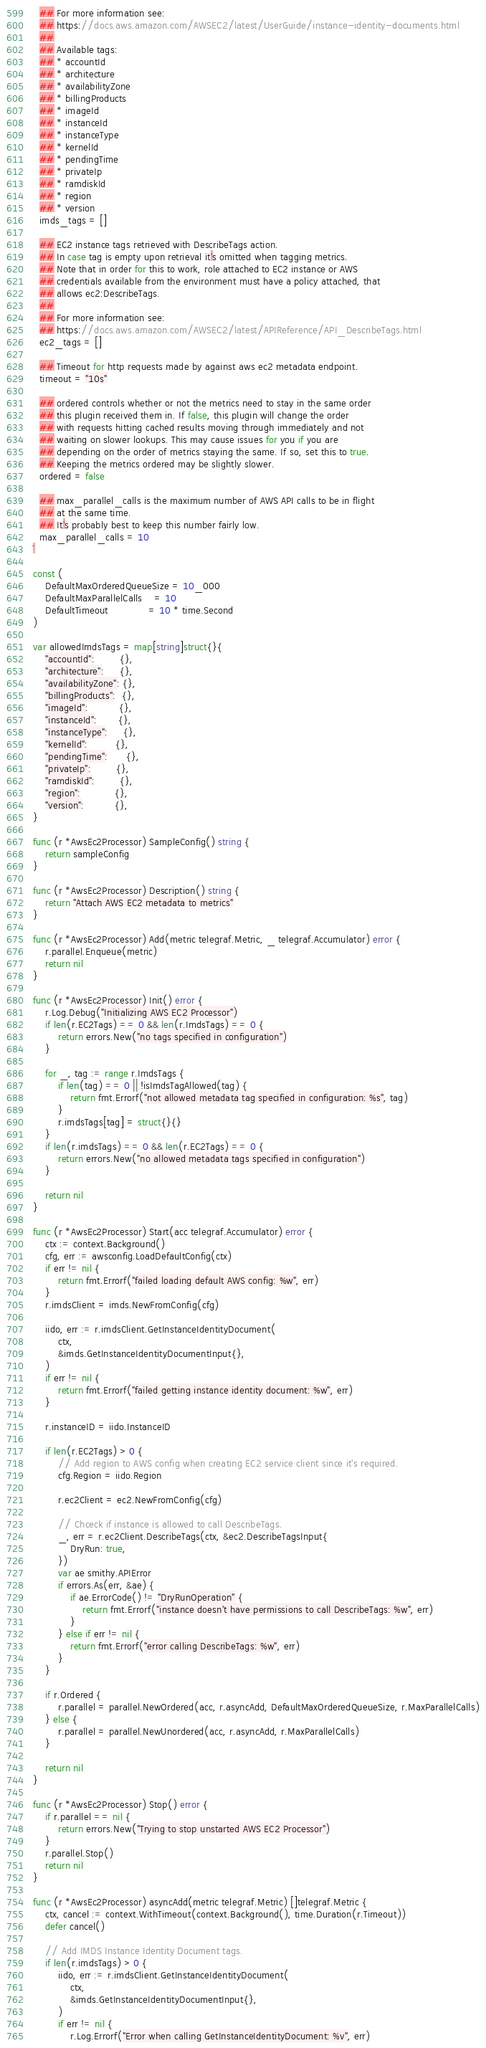Convert code to text. <code><loc_0><loc_0><loc_500><loc_500><_Go_>  ## For more information see:
  ## https://docs.aws.amazon.com/AWSEC2/latest/UserGuide/instance-identity-documents.html
  ##
  ## Available tags:
  ## * accountId
  ## * architecture
  ## * availabilityZone
  ## * billingProducts
  ## * imageId
  ## * instanceId
  ## * instanceType
  ## * kernelId
  ## * pendingTime
  ## * privateIp
  ## * ramdiskId
  ## * region
  ## * version
  imds_tags = []

  ## EC2 instance tags retrieved with DescribeTags action.
  ## In case tag is empty upon retrieval it's omitted when tagging metrics.
  ## Note that in order for this to work, role attached to EC2 instance or AWS
  ## credentials available from the environment must have a policy attached, that
  ## allows ec2:DescribeTags.
  ##
  ## For more information see:
  ## https://docs.aws.amazon.com/AWSEC2/latest/APIReference/API_DescribeTags.html
  ec2_tags = []

  ## Timeout for http requests made by against aws ec2 metadata endpoint.
  timeout = "10s"

  ## ordered controls whether or not the metrics need to stay in the same order
  ## this plugin received them in. If false, this plugin will change the order
  ## with requests hitting cached results moving through immediately and not
  ## waiting on slower lookups. This may cause issues for you if you are
  ## depending on the order of metrics staying the same. If so, set this to true.
  ## Keeping the metrics ordered may be slightly slower.
  ordered = false

  ## max_parallel_calls is the maximum number of AWS API calls to be in flight
  ## at the same time.
  ## It's probably best to keep this number fairly low.
  max_parallel_calls = 10
`

const (
	DefaultMaxOrderedQueueSize = 10_000
	DefaultMaxParallelCalls    = 10
	DefaultTimeout             = 10 * time.Second
)

var allowedImdsTags = map[string]struct{}{
	"accountId":        {},
	"architecture":     {},
	"availabilityZone": {},
	"billingProducts":  {},
	"imageId":          {},
	"instanceId":       {},
	"instanceType":     {},
	"kernelId":         {},
	"pendingTime":      {},
	"privateIp":        {},
	"ramdiskId":        {},
	"region":           {},
	"version":          {},
}

func (r *AwsEc2Processor) SampleConfig() string {
	return sampleConfig
}

func (r *AwsEc2Processor) Description() string {
	return "Attach AWS EC2 metadata to metrics"
}

func (r *AwsEc2Processor) Add(metric telegraf.Metric, _ telegraf.Accumulator) error {
	r.parallel.Enqueue(metric)
	return nil
}

func (r *AwsEc2Processor) Init() error {
	r.Log.Debug("Initializing AWS EC2 Processor")
	if len(r.EC2Tags) == 0 && len(r.ImdsTags) == 0 {
		return errors.New("no tags specified in configuration")
	}

	for _, tag := range r.ImdsTags {
		if len(tag) == 0 || !isImdsTagAllowed(tag) {
			return fmt.Errorf("not allowed metadata tag specified in configuration: %s", tag)
		}
		r.imdsTags[tag] = struct{}{}
	}
	if len(r.imdsTags) == 0 && len(r.EC2Tags) == 0 {
		return errors.New("no allowed metadata tags specified in configuration")
	}

	return nil
}

func (r *AwsEc2Processor) Start(acc telegraf.Accumulator) error {
	ctx := context.Background()
	cfg, err := awsconfig.LoadDefaultConfig(ctx)
	if err != nil {
		return fmt.Errorf("failed loading default AWS config: %w", err)
	}
	r.imdsClient = imds.NewFromConfig(cfg)

	iido, err := r.imdsClient.GetInstanceIdentityDocument(
		ctx,
		&imds.GetInstanceIdentityDocumentInput{},
	)
	if err != nil {
		return fmt.Errorf("failed getting instance identity document: %w", err)
	}

	r.instanceID = iido.InstanceID

	if len(r.EC2Tags) > 0 {
		// Add region to AWS config when creating EC2 service client since it's required.
		cfg.Region = iido.Region

		r.ec2Client = ec2.NewFromConfig(cfg)

		// Chceck if instance is allowed to call DescribeTags.
		_, err = r.ec2Client.DescribeTags(ctx, &ec2.DescribeTagsInput{
			DryRun: true,
		})
		var ae smithy.APIError
		if errors.As(err, &ae) {
			if ae.ErrorCode() != "DryRunOperation" {
				return fmt.Errorf("instance doesn't have permissions to call DescribeTags: %w", err)
			}
		} else if err != nil {
			return fmt.Errorf("error calling DescribeTags: %w", err)
		}
	}

	if r.Ordered {
		r.parallel = parallel.NewOrdered(acc, r.asyncAdd, DefaultMaxOrderedQueueSize, r.MaxParallelCalls)
	} else {
		r.parallel = parallel.NewUnordered(acc, r.asyncAdd, r.MaxParallelCalls)
	}

	return nil
}

func (r *AwsEc2Processor) Stop() error {
	if r.parallel == nil {
		return errors.New("Trying to stop unstarted AWS EC2 Processor")
	}
	r.parallel.Stop()
	return nil
}

func (r *AwsEc2Processor) asyncAdd(metric telegraf.Metric) []telegraf.Metric {
	ctx, cancel := context.WithTimeout(context.Background(), time.Duration(r.Timeout))
	defer cancel()

	// Add IMDS Instance Identity Document tags.
	if len(r.imdsTags) > 0 {
		iido, err := r.imdsClient.GetInstanceIdentityDocument(
			ctx,
			&imds.GetInstanceIdentityDocumentInput{},
		)
		if err != nil {
			r.Log.Errorf("Error when calling GetInstanceIdentityDocument: %v", err)</code> 